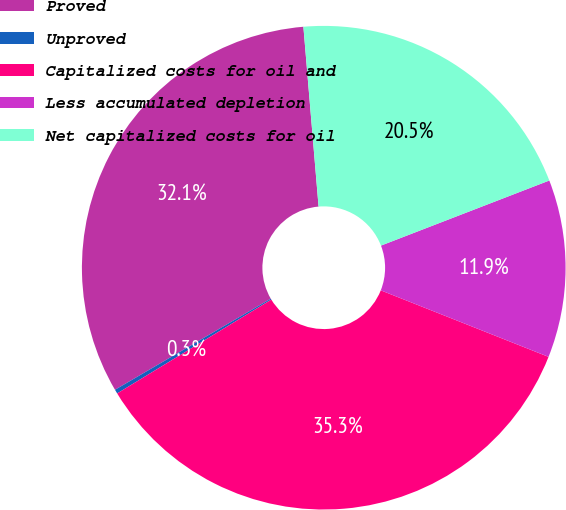<chart> <loc_0><loc_0><loc_500><loc_500><pie_chart><fcel>Proved<fcel>Unproved<fcel>Capitalized costs for oil and<fcel>Less accumulated depletion<fcel>Net capitalized costs for oil<nl><fcel>32.08%<fcel>0.28%<fcel>35.29%<fcel>11.88%<fcel>20.47%<nl></chart> 